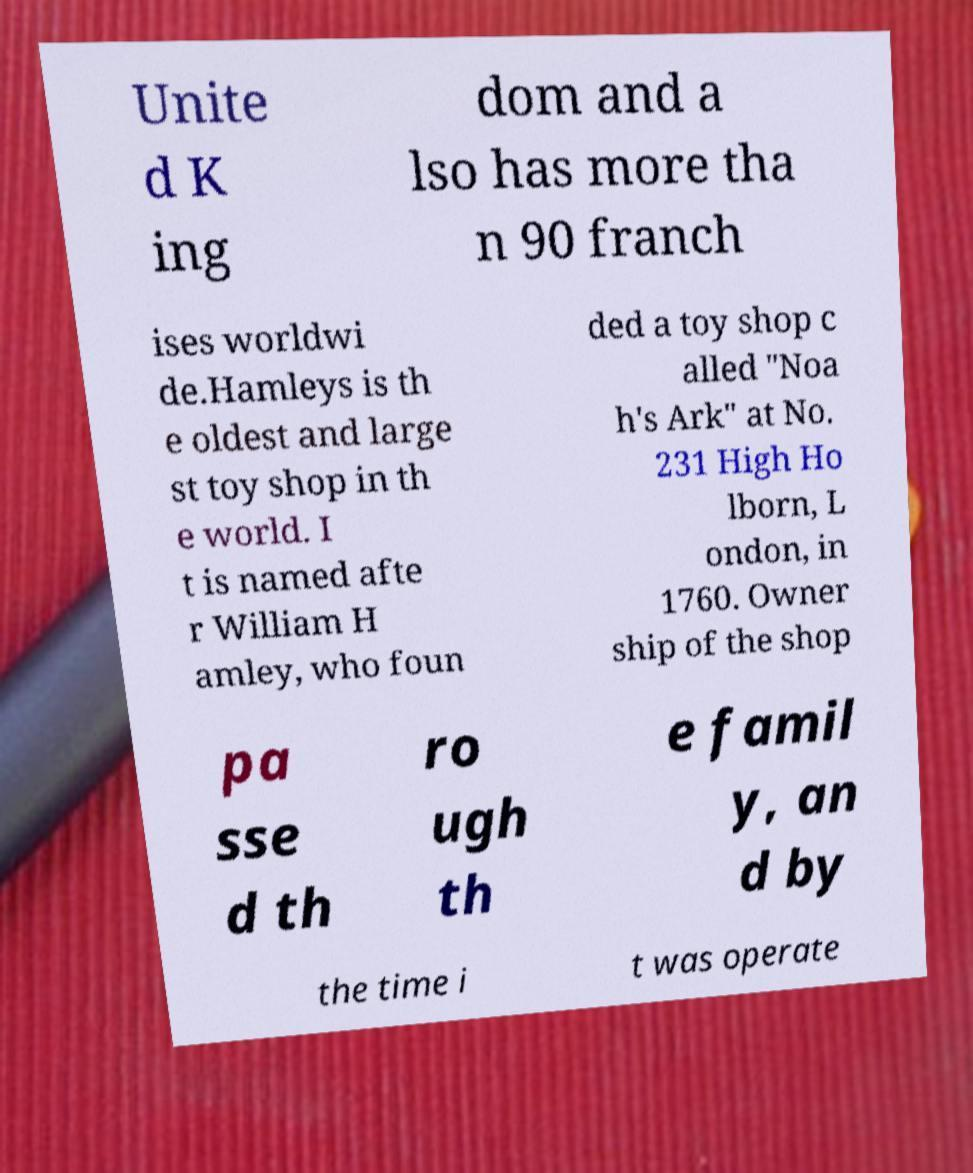What messages or text are displayed in this image? I need them in a readable, typed format. Unite d K ing dom and a lso has more tha n 90 franch ises worldwi de.Hamleys is th e oldest and large st toy shop in th e world. I t is named afte r William H amley, who foun ded a toy shop c alled "Noa h's Ark" at No. 231 High Ho lborn, L ondon, in 1760. Owner ship of the shop pa sse d th ro ugh th e famil y, an d by the time i t was operate 